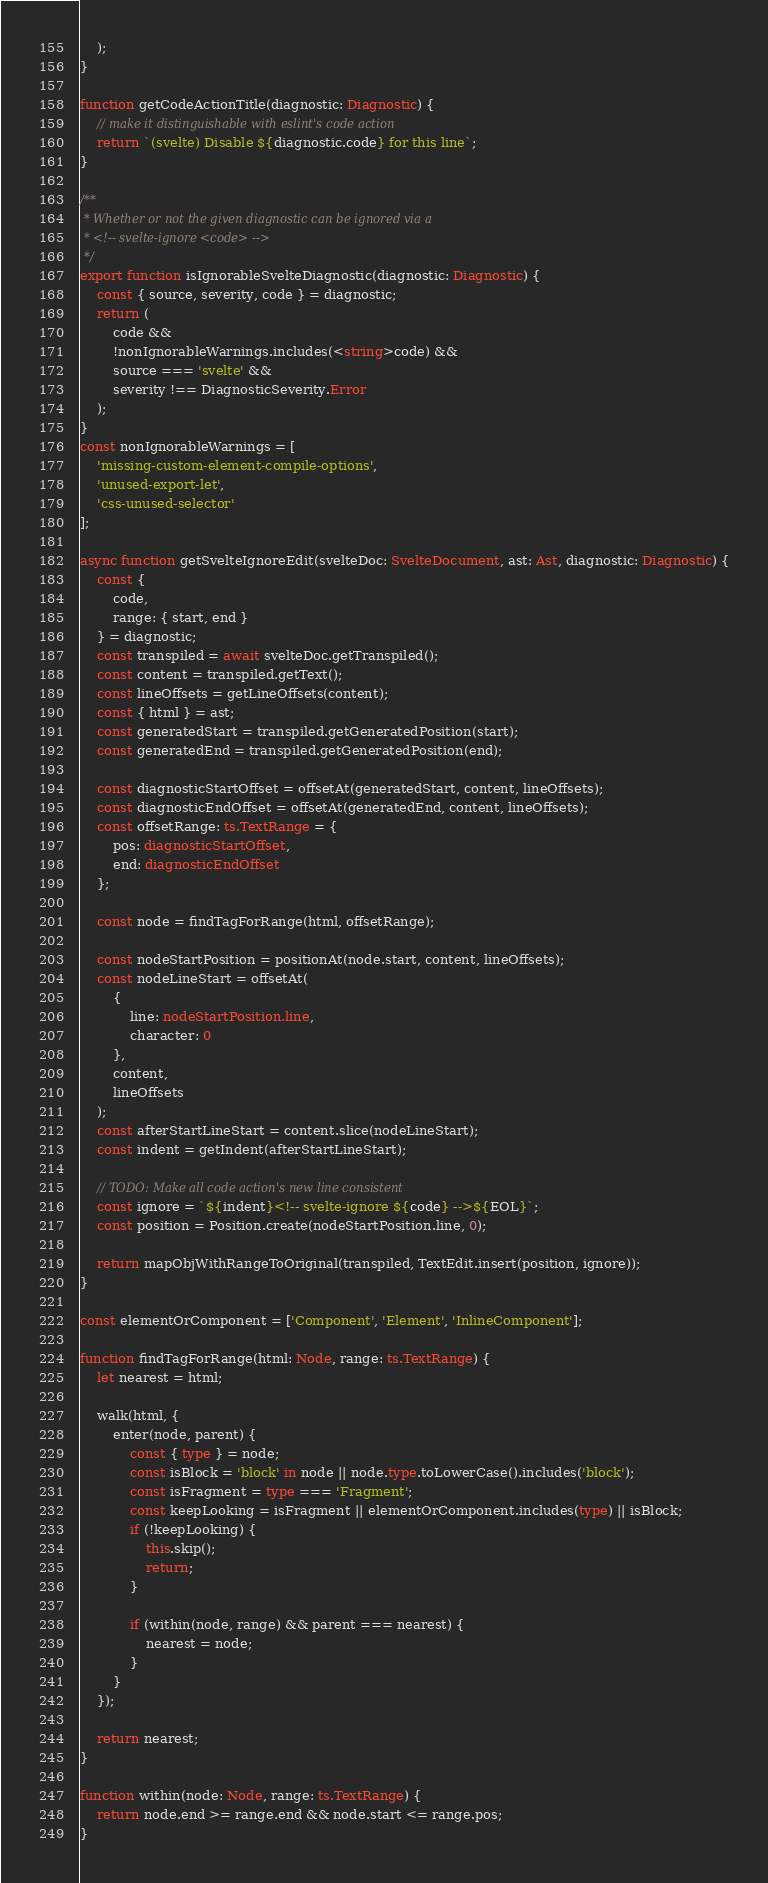<code> <loc_0><loc_0><loc_500><loc_500><_TypeScript_>    );
}

function getCodeActionTitle(diagnostic: Diagnostic) {
    // make it distinguishable with eslint's code action
    return `(svelte) Disable ${diagnostic.code} for this line`;
}

/**
 * Whether or not the given diagnostic can be ignored via a
 * <!-- svelte-ignore <code> -->
 */
export function isIgnorableSvelteDiagnostic(diagnostic: Diagnostic) {
    const { source, severity, code } = diagnostic;
    return (
        code &&
        !nonIgnorableWarnings.includes(<string>code) &&
        source === 'svelte' &&
        severity !== DiagnosticSeverity.Error
    );
}
const nonIgnorableWarnings = [
    'missing-custom-element-compile-options',
    'unused-export-let',
    'css-unused-selector'
];

async function getSvelteIgnoreEdit(svelteDoc: SvelteDocument, ast: Ast, diagnostic: Diagnostic) {
    const {
        code,
        range: { start, end }
    } = diagnostic;
    const transpiled = await svelteDoc.getTranspiled();
    const content = transpiled.getText();
    const lineOffsets = getLineOffsets(content);
    const { html } = ast;
    const generatedStart = transpiled.getGeneratedPosition(start);
    const generatedEnd = transpiled.getGeneratedPosition(end);

    const diagnosticStartOffset = offsetAt(generatedStart, content, lineOffsets);
    const diagnosticEndOffset = offsetAt(generatedEnd, content, lineOffsets);
    const offsetRange: ts.TextRange = {
        pos: diagnosticStartOffset,
        end: diagnosticEndOffset
    };

    const node = findTagForRange(html, offsetRange);

    const nodeStartPosition = positionAt(node.start, content, lineOffsets);
    const nodeLineStart = offsetAt(
        {
            line: nodeStartPosition.line,
            character: 0
        },
        content,
        lineOffsets
    );
    const afterStartLineStart = content.slice(nodeLineStart);
    const indent = getIndent(afterStartLineStart);

    // TODO: Make all code action's new line consistent
    const ignore = `${indent}<!-- svelte-ignore ${code} -->${EOL}`;
    const position = Position.create(nodeStartPosition.line, 0);

    return mapObjWithRangeToOriginal(transpiled, TextEdit.insert(position, ignore));
}

const elementOrComponent = ['Component', 'Element', 'InlineComponent'];

function findTagForRange(html: Node, range: ts.TextRange) {
    let nearest = html;

    walk(html, {
        enter(node, parent) {
            const { type } = node;
            const isBlock = 'block' in node || node.type.toLowerCase().includes('block');
            const isFragment = type === 'Fragment';
            const keepLooking = isFragment || elementOrComponent.includes(type) || isBlock;
            if (!keepLooking) {
                this.skip();
                return;
            }

            if (within(node, range) && parent === nearest) {
                nearest = node;
            }
        }
    });

    return nearest;
}

function within(node: Node, range: ts.TextRange) {
    return node.end >= range.end && node.start <= range.pos;
}
</code> 